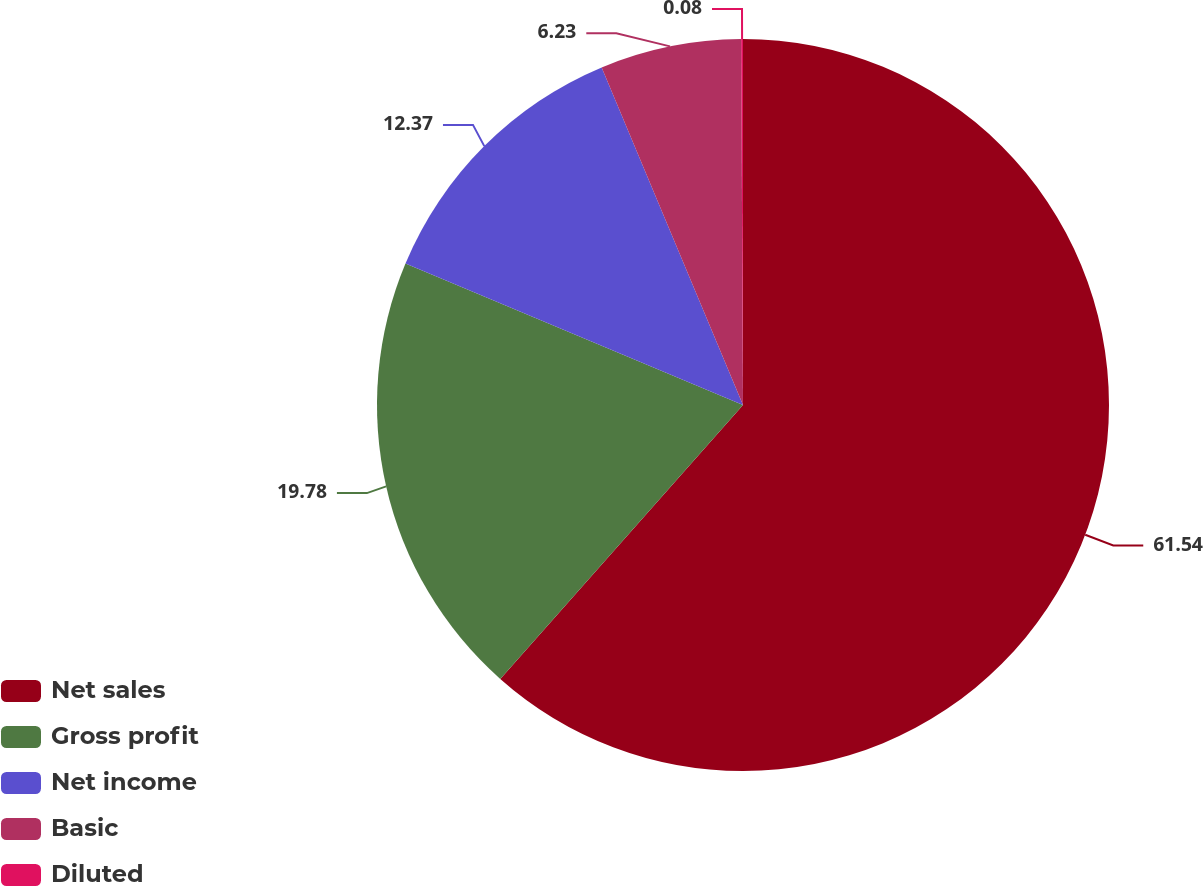Convert chart. <chart><loc_0><loc_0><loc_500><loc_500><pie_chart><fcel>Net sales<fcel>Gross profit<fcel>Net income<fcel>Basic<fcel>Diluted<nl><fcel>61.54%<fcel>19.78%<fcel>12.37%<fcel>6.23%<fcel>0.08%<nl></chart> 